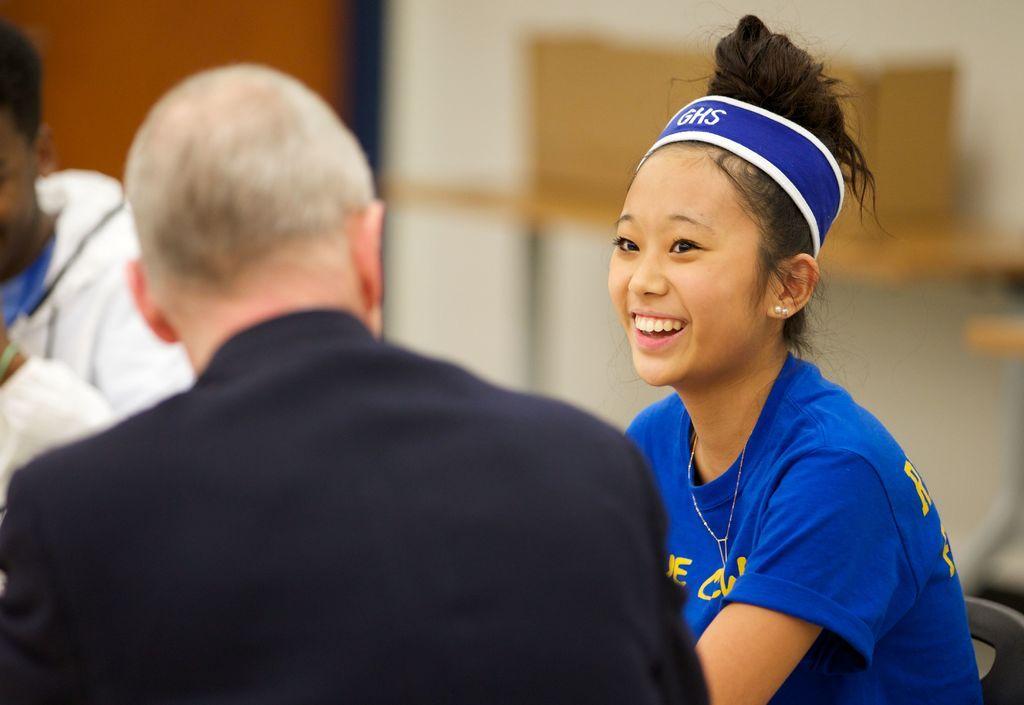In one or two sentences, can you explain what this image depicts? In this image we can see a group of people sitting on chairs. In the background, we can see a table and a door. 